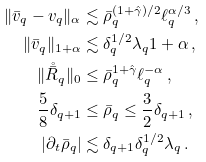Convert formula to latex. <formula><loc_0><loc_0><loc_500><loc_500>\| \bar { v } _ { q } - v _ { q } \| _ { \alpha } & \lesssim \bar { \rho } _ { q } ^ { ( 1 + \hat { \gamma } ) / 2 } \ell _ { q } ^ { \alpha / 3 } \, , \\ \| \bar { v } _ { q } \| _ { 1 + \alpha } & \lesssim \delta _ { q } ^ { 1 / 2 } \lambda _ { q } { 1 + \alpha } \, , \\ \| \mathring { \bar { R } } _ { q } \| _ { 0 } & \leq \bar { \rho } _ { q } ^ { 1 + { \hat { \gamma } } } \ell _ { q } ^ { - \alpha } \, , \\ \frac { 5 } { 8 } \delta _ { q + 1 } & \leq \bar { \rho } _ { q } \leq \frac { 3 } { 2 } \delta _ { q + 1 } \, , \\ | \partial _ { t } \bar { \rho } _ { q } | & \lesssim \delta _ { q + 1 } \delta _ { q } ^ { 1 / 2 } \lambda _ { q } \, .</formula> 